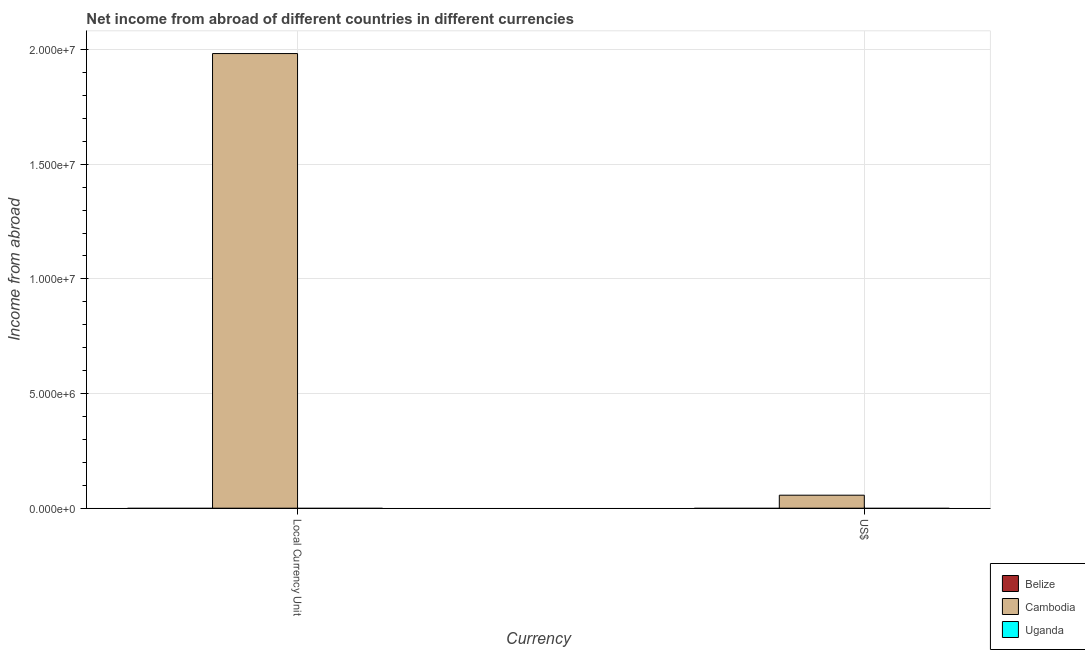Are the number of bars on each tick of the X-axis equal?
Ensure brevity in your answer.  Yes. What is the label of the 2nd group of bars from the left?
Make the answer very short. US$. Across all countries, what is the maximum income from abroad in us$?
Your response must be concise. 5.67e+05. In which country was the income from abroad in us$ maximum?
Your response must be concise. Cambodia. What is the total income from abroad in constant 2005 us$ in the graph?
Ensure brevity in your answer.  1.98e+07. What is the difference between the income from abroad in us$ in Cambodia and the income from abroad in constant 2005 us$ in Belize?
Your answer should be compact. 5.67e+05. What is the average income from abroad in constant 2005 us$ per country?
Provide a succinct answer. 6.61e+06. What is the difference between the income from abroad in us$ and income from abroad in constant 2005 us$ in Cambodia?
Keep it short and to the point. -1.93e+07. In how many countries, is the income from abroad in constant 2005 us$ greater than 12000000 units?
Offer a very short reply. 1. In how many countries, is the income from abroad in us$ greater than the average income from abroad in us$ taken over all countries?
Your answer should be compact. 1. Are all the bars in the graph horizontal?
Ensure brevity in your answer.  No. What is the difference between two consecutive major ticks on the Y-axis?
Make the answer very short. 5.00e+06. Are the values on the major ticks of Y-axis written in scientific E-notation?
Make the answer very short. Yes. Does the graph contain any zero values?
Make the answer very short. Yes. Does the graph contain grids?
Provide a short and direct response. Yes. What is the title of the graph?
Make the answer very short. Net income from abroad of different countries in different currencies. Does "Micronesia" appear as one of the legend labels in the graph?
Ensure brevity in your answer.  No. What is the label or title of the X-axis?
Provide a short and direct response. Currency. What is the label or title of the Y-axis?
Keep it short and to the point. Income from abroad. What is the Income from abroad of Cambodia in Local Currency Unit?
Keep it short and to the point. 1.98e+07. What is the Income from abroad in Cambodia in US$?
Give a very brief answer. 5.67e+05. Across all Currency, what is the maximum Income from abroad in Cambodia?
Your answer should be very brief. 1.98e+07. Across all Currency, what is the minimum Income from abroad in Cambodia?
Your answer should be compact. 5.67e+05. What is the total Income from abroad of Cambodia in the graph?
Your response must be concise. 2.04e+07. What is the total Income from abroad of Uganda in the graph?
Make the answer very short. 0. What is the difference between the Income from abroad of Cambodia in Local Currency Unit and that in US$?
Give a very brief answer. 1.93e+07. What is the average Income from abroad of Cambodia per Currency?
Ensure brevity in your answer.  1.02e+07. What is the average Income from abroad of Uganda per Currency?
Provide a succinct answer. 0. What is the ratio of the Income from abroad of Cambodia in Local Currency Unit to that in US$?
Offer a terse response. 35. What is the difference between the highest and the second highest Income from abroad in Cambodia?
Offer a terse response. 1.93e+07. What is the difference between the highest and the lowest Income from abroad of Cambodia?
Make the answer very short. 1.93e+07. 